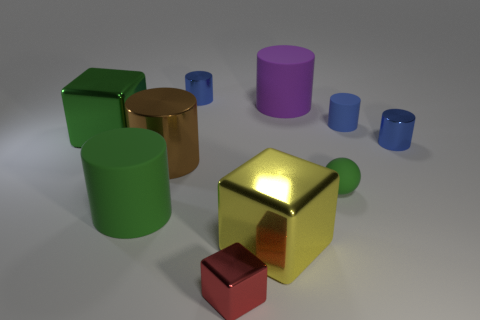Which objects in the image would be considered geometrically cylindrical? In this image, the objects that are geometrically cylindrical are the two standing cylinders, one large green and one smaller purple, as well as the three small lying cylinders in blue. 